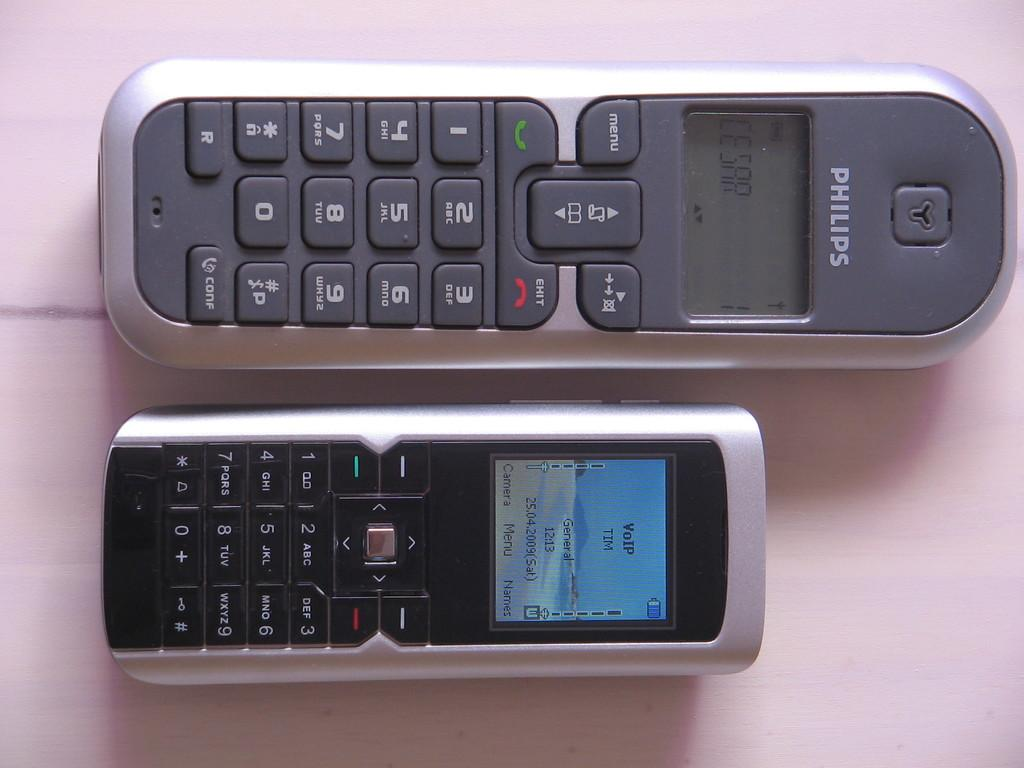<image>
Share a concise interpretation of the image provided. Two cell phones with VoIP from Phillips phones 